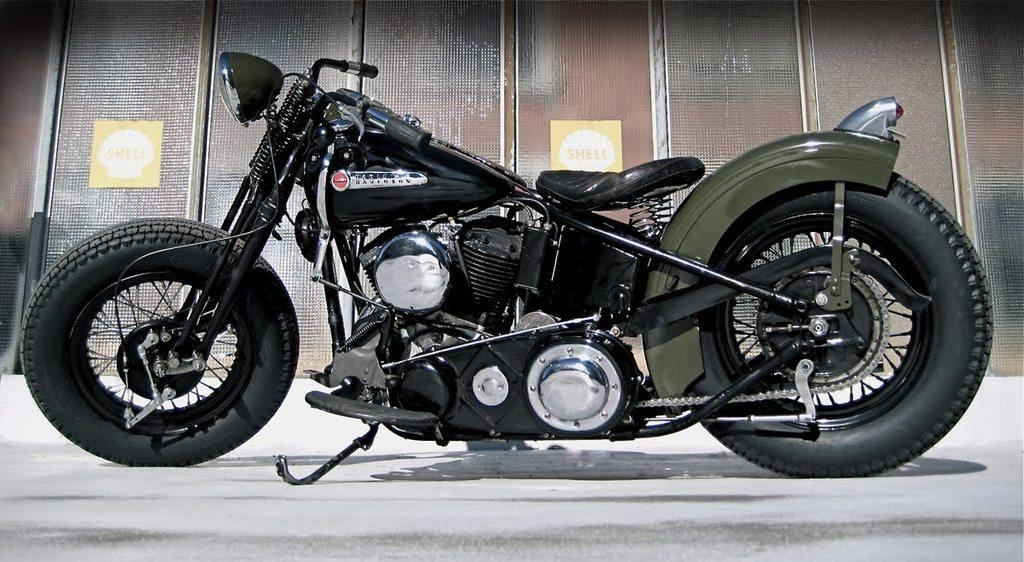What type of vehicle is in the image? There is a green and black motorcycle in the image. Where is the motorcycle located in the image? The motorcycle is in the front of the image. What can be seen in the background of the image? There are two boards on the wall in the background of the image. What is written on the boards? Words are written on the boards. What type of arch can be seen in the image? There is no arch present in the image. What meal is being prepared on the motorcycle? The image does not depict a meal or any food preparation; it features a motorcycle and two boards with words on them. 